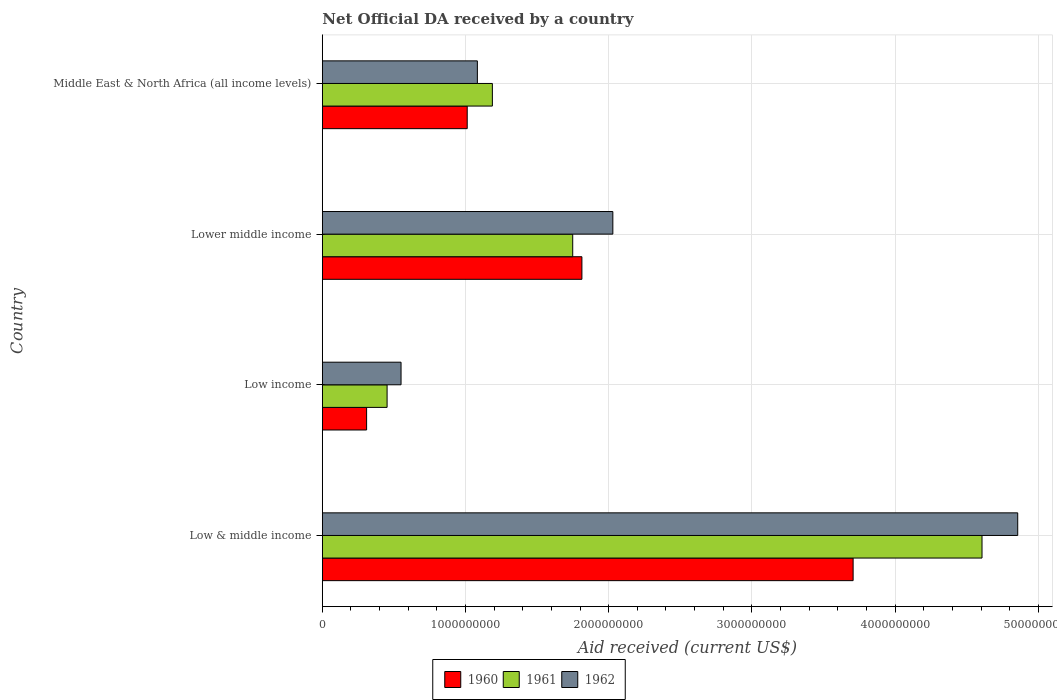How many different coloured bars are there?
Your answer should be very brief. 3. Are the number of bars per tick equal to the number of legend labels?
Offer a terse response. Yes. Are the number of bars on each tick of the Y-axis equal?
Keep it short and to the point. Yes. What is the label of the 1st group of bars from the top?
Offer a very short reply. Middle East & North Africa (all income levels). What is the net official development assistance aid received in 1960 in Lower middle income?
Your response must be concise. 1.81e+09. Across all countries, what is the maximum net official development assistance aid received in 1960?
Offer a terse response. 3.71e+09. Across all countries, what is the minimum net official development assistance aid received in 1960?
Provide a succinct answer. 3.09e+08. What is the total net official development assistance aid received in 1962 in the graph?
Your response must be concise. 8.52e+09. What is the difference between the net official development assistance aid received in 1960 in Low & middle income and that in Lower middle income?
Offer a very short reply. 1.89e+09. What is the difference between the net official development assistance aid received in 1961 in Low & middle income and the net official development assistance aid received in 1962 in Middle East & North Africa (all income levels)?
Give a very brief answer. 3.52e+09. What is the average net official development assistance aid received in 1960 per country?
Offer a very short reply. 1.71e+09. What is the difference between the net official development assistance aid received in 1960 and net official development assistance aid received in 1962 in Middle East & North Africa (all income levels)?
Your answer should be very brief. -7.09e+07. In how many countries, is the net official development assistance aid received in 1961 greater than 3000000000 US$?
Your answer should be compact. 1. What is the ratio of the net official development assistance aid received in 1960 in Low income to that in Middle East & North Africa (all income levels)?
Give a very brief answer. 0.31. Is the net official development assistance aid received in 1960 in Low & middle income less than that in Low income?
Provide a succinct answer. No. Is the difference between the net official development assistance aid received in 1960 in Lower middle income and Middle East & North Africa (all income levels) greater than the difference between the net official development assistance aid received in 1962 in Lower middle income and Middle East & North Africa (all income levels)?
Make the answer very short. No. What is the difference between the highest and the second highest net official development assistance aid received in 1960?
Give a very brief answer. 1.89e+09. What is the difference between the highest and the lowest net official development assistance aid received in 1961?
Your response must be concise. 4.15e+09. In how many countries, is the net official development assistance aid received in 1961 greater than the average net official development assistance aid received in 1961 taken over all countries?
Provide a succinct answer. 1. What does the 2nd bar from the bottom in Low income represents?
Ensure brevity in your answer.  1961. Are all the bars in the graph horizontal?
Your answer should be very brief. Yes. How many countries are there in the graph?
Offer a very short reply. 4. Are the values on the major ticks of X-axis written in scientific E-notation?
Provide a succinct answer. No. Does the graph contain grids?
Your answer should be very brief. Yes. Where does the legend appear in the graph?
Offer a very short reply. Bottom center. How many legend labels are there?
Your answer should be very brief. 3. How are the legend labels stacked?
Ensure brevity in your answer.  Horizontal. What is the title of the graph?
Ensure brevity in your answer.  Net Official DA received by a country. Does "1994" appear as one of the legend labels in the graph?
Keep it short and to the point. No. What is the label or title of the X-axis?
Keep it short and to the point. Aid received (current US$). What is the Aid received (current US$) in 1960 in Low & middle income?
Make the answer very short. 3.71e+09. What is the Aid received (current US$) of 1961 in Low & middle income?
Provide a short and direct response. 4.61e+09. What is the Aid received (current US$) of 1962 in Low & middle income?
Give a very brief answer. 4.86e+09. What is the Aid received (current US$) in 1960 in Low income?
Make the answer very short. 3.09e+08. What is the Aid received (current US$) of 1961 in Low income?
Your answer should be compact. 4.52e+08. What is the Aid received (current US$) in 1962 in Low income?
Your answer should be compact. 5.50e+08. What is the Aid received (current US$) in 1960 in Lower middle income?
Offer a terse response. 1.81e+09. What is the Aid received (current US$) of 1961 in Lower middle income?
Your response must be concise. 1.75e+09. What is the Aid received (current US$) in 1962 in Lower middle income?
Offer a terse response. 2.03e+09. What is the Aid received (current US$) in 1960 in Middle East & North Africa (all income levels)?
Offer a very short reply. 1.01e+09. What is the Aid received (current US$) of 1961 in Middle East & North Africa (all income levels)?
Your response must be concise. 1.19e+09. What is the Aid received (current US$) in 1962 in Middle East & North Africa (all income levels)?
Offer a very short reply. 1.08e+09. Across all countries, what is the maximum Aid received (current US$) in 1960?
Provide a short and direct response. 3.71e+09. Across all countries, what is the maximum Aid received (current US$) of 1961?
Your answer should be very brief. 4.61e+09. Across all countries, what is the maximum Aid received (current US$) of 1962?
Keep it short and to the point. 4.86e+09. Across all countries, what is the minimum Aid received (current US$) in 1960?
Give a very brief answer. 3.09e+08. Across all countries, what is the minimum Aid received (current US$) in 1961?
Provide a succinct answer. 4.52e+08. Across all countries, what is the minimum Aid received (current US$) in 1962?
Keep it short and to the point. 5.50e+08. What is the total Aid received (current US$) of 1960 in the graph?
Offer a very short reply. 6.84e+09. What is the total Aid received (current US$) in 1961 in the graph?
Your response must be concise. 8.00e+09. What is the total Aid received (current US$) in 1962 in the graph?
Make the answer very short. 8.52e+09. What is the difference between the Aid received (current US$) of 1960 in Low & middle income and that in Low income?
Your answer should be very brief. 3.40e+09. What is the difference between the Aid received (current US$) in 1961 in Low & middle income and that in Low income?
Your answer should be very brief. 4.15e+09. What is the difference between the Aid received (current US$) of 1962 in Low & middle income and that in Low income?
Ensure brevity in your answer.  4.31e+09. What is the difference between the Aid received (current US$) in 1960 in Low & middle income and that in Lower middle income?
Your answer should be compact. 1.89e+09. What is the difference between the Aid received (current US$) in 1961 in Low & middle income and that in Lower middle income?
Offer a very short reply. 2.86e+09. What is the difference between the Aid received (current US$) in 1962 in Low & middle income and that in Lower middle income?
Your response must be concise. 2.83e+09. What is the difference between the Aid received (current US$) in 1960 in Low & middle income and that in Middle East & North Africa (all income levels)?
Offer a terse response. 2.70e+09. What is the difference between the Aid received (current US$) in 1961 in Low & middle income and that in Middle East & North Africa (all income levels)?
Make the answer very short. 3.42e+09. What is the difference between the Aid received (current US$) of 1962 in Low & middle income and that in Middle East & North Africa (all income levels)?
Your response must be concise. 3.77e+09. What is the difference between the Aid received (current US$) of 1960 in Low income and that in Lower middle income?
Make the answer very short. -1.50e+09. What is the difference between the Aid received (current US$) in 1961 in Low income and that in Lower middle income?
Your answer should be very brief. -1.30e+09. What is the difference between the Aid received (current US$) of 1962 in Low income and that in Lower middle income?
Make the answer very short. -1.48e+09. What is the difference between the Aid received (current US$) of 1960 in Low income and that in Middle East & North Africa (all income levels)?
Offer a very short reply. -7.03e+08. What is the difference between the Aid received (current US$) in 1961 in Low income and that in Middle East & North Africa (all income levels)?
Make the answer very short. -7.35e+08. What is the difference between the Aid received (current US$) of 1962 in Low income and that in Middle East & North Africa (all income levels)?
Provide a succinct answer. -5.33e+08. What is the difference between the Aid received (current US$) in 1960 in Lower middle income and that in Middle East & North Africa (all income levels)?
Provide a succinct answer. 8.01e+08. What is the difference between the Aid received (current US$) in 1961 in Lower middle income and that in Middle East & North Africa (all income levels)?
Provide a succinct answer. 5.61e+08. What is the difference between the Aid received (current US$) in 1962 in Lower middle income and that in Middle East & North Africa (all income levels)?
Your response must be concise. 9.46e+08. What is the difference between the Aid received (current US$) of 1960 in Low & middle income and the Aid received (current US$) of 1961 in Low income?
Keep it short and to the point. 3.25e+09. What is the difference between the Aid received (current US$) in 1960 in Low & middle income and the Aid received (current US$) in 1962 in Low income?
Make the answer very short. 3.16e+09. What is the difference between the Aid received (current US$) of 1961 in Low & middle income and the Aid received (current US$) of 1962 in Low income?
Your answer should be very brief. 4.06e+09. What is the difference between the Aid received (current US$) in 1960 in Low & middle income and the Aid received (current US$) in 1961 in Lower middle income?
Provide a succinct answer. 1.96e+09. What is the difference between the Aid received (current US$) of 1960 in Low & middle income and the Aid received (current US$) of 1962 in Lower middle income?
Keep it short and to the point. 1.68e+09. What is the difference between the Aid received (current US$) of 1961 in Low & middle income and the Aid received (current US$) of 1962 in Lower middle income?
Make the answer very short. 2.58e+09. What is the difference between the Aid received (current US$) of 1960 in Low & middle income and the Aid received (current US$) of 1961 in Middle East & North Africa (all income levels)?
Keep it short and to the point. 2.52e+09. What is the difference between the Aid received (current US$) in 1960 in Low & middle income and the Aid received (current US$) in 1962 in Middle East & North Africa (all income levels)?
Give a very brief answer. 2.62e+09. What is the difference between the Aid received (current US$) of 1961 in Low & middle income and the Aid received (current US$) of 1962 in Middle East & North Africa (all income levels)?
Ensure brevity in your answer.  3.52e+09. What is the difference between the Aid received (current US$) of 1960 in Low income and the Aid received (current US$) of 1961 in Lower middle income?
Your answer should be compact. -1.44e+09. What is the difference between the Aid received (current US$) of 1960 in Low income and the Aid received (current US$) of 1962 in Lower middle income?
Offer a terse response. -1.72e+09. What is the difference between the Aid received (current US$) in 1961 in Low income and the Aid received (current US$) in 1962 in Lower middle income?
Offer a very short reply. -1.58e+09. What is the difference between the Aid received (current US$) in 1960 in Low income and the Aid received (current US$) in 1961 in Middle East & North Africa (all income levels)?
Provide a succinct answer. -8.78e+08. What is the difference between the Aid received (current US$) in 1960 in Low income and the Aid received (current US$) in 1962 in Middle East & North Africa (all income levels)?
Your response must be concise. -7.74e+08. What is the difference between the Aid received (current US$) in 1961 in Low income and the Aid received (current US$) in 1962 in Middle East & North Africa (all income levels)?
Provide a succinct answer. -6.30e+08. What is the difference between the Aid received (current US$) of 1960 in Lower middle income and the Aid received (current US$) of 1961 in Middle East & North Africa (all income levels)?
Give a very brief answer. 6.25e+08. What is the difference between the Aid received (current US$) of 1960 in Lower middle income and the Aid received (current US$) of 1962 in Middle East & North Africa (all income levels)?
Offer a terse response. 7.30e+08. What is the difference between the Aid received (current US$) in 1961 in Lower middle income and the Aid received (current US$) in 1962 in Middle East & North Africa (all income levels)?
Provide a short and direct response. 6.66e+08. What is the average Aid received (current US$) in 1960 per country?
Your answer should be compact. 1.71e+09. What is the average Aid received (current US$) of 1961 per country?
Provide a short and direct response. 2.00e+09. What is the average Aid received (current US$) in 1962 per country?
Offer a terse response. 2.13e+09. What is the difference between the Aid received (current US$) in 1960 and Aid received (current US$) in 1961 in Low & middle income?
Your answer should be compact. -9.00e+08. What is the difference between the Aid received (current US$) of 1960 and Aid received (current US$) of 1962 in Low & middle income?
Make the answer very short. -1.15e+09. What is the difference between the Aid received (current US$) in 1961 and Aid received (current US$) in 1962 in Low & middle income?
Make the answer very short. -2.49e+08. What is the difference between the Aid received (current US$) of 1960 and Aid received (current US$) of 1961 in Low income?
Keep it short and to the point. -1.43e+08. What is the difference between the Aid received (current US$) in 1960 and Aid received (current US$) in 1962 in Low income?
Keep it short and to the point. -2.41e+08. What is the difference between the Aid received (current US$) in 1961 and Aid received (current US$) in 1962 in Low income?
Your answer should be very brief. -9.75e+07. What is the difference between the Aid received (current US$) in 1960 and Aid received (current US$) in 1961 in Lower middle income?
Keep it short and to the point. 6.42e+07. What is the difference between the Aid received (current US$) in 1960 and Aid received (current US$) in 1962 in Lower middle income?
Keep it short and to the point. -2.16e+08. What is the difference between the Aid received (current US$) of 1961 and Aid received (current US$) of 1962 in Lower middle income?
Keep it short and to the point. -2.80e+08. What is the difference between the Aid received (current US$) of 1960 and Aid received (current US$) of 1961 in Middle East & North Africa (all income levels)?
Keep it short and to the point. -1.76e+08. What is the difference between the Aid received (current US$) of 1960 and Aid received (current US$) of 1962 in Middle East & North Africa (all income levels)?
Offer a very short reply. -7.09e+07. What is the difference between the Aid received (current US$) of 1961 and Aid received (current US$) of 1962 in Middle East & North Africa (all income levels)?
Offer a terse response. 1.05e+08. What is the ratio of the Aid received (current US$) in 1960 in Low & middle income to that in Low income?
Your response must be concise. 11.99. What is the ratio of the Aid received (current US$) in 1961 in Low & middle income to that in Low income?
Give a very brief answer. 10.19. What is the ratio of the Aid received (current US$) in 1962 in Low & middle income to that in Low income?
Your answer should be very brief. 8.83. What is the ratio of the Aid received (current US$) in 1960 in Low & middle income to that in Lower middle income?
Make the answer very short. 2.04. What is the ratio of the Aid received (current US$) of 1961 in Low & middle income to that in Lower middle income?
Offer a terse response. 2.63. What is the ratio of the Aid received (current US$) in 1962 in Low & middle income to that in Lower middle income?
Your answer should be compact. 2.39. What is the ratio of the Aid received (current US$) in 1960 in Low & middle income to that in Middle East & North Africa (all income levels)?
Your answer should be compact. 3.66. What is the ratio of the Aid received (current US$) in 1961 in Low & middle income to that in Middle East & North Africa (all income levels)?
Provide a succinct answer. 3.88. What is the ratio of the Aid received (current US$) in 1962 in Low & middle income to that in Middle East & North Africa (all income levels)?
Your answer should be very brief. 4.49. What is the ratio of the Aid received (current US$) of 1960 in Low income to that in Lower middle income?
Offer a terse response. 0.17. What is the ratio of the Aid received (current US$) of 1961 in Low income to that in Lower middle income?
Make the answer very short. 0.26. What is the ratio of the Aid received (current US$) in 1962 in Low income to that in Lower middle income?
Ensure brevity in your answer.  0.27. What is the ratio of the Aid received (current US$) in 1960 in Low income to that in Middle East & North Africa (all income levels)?
Offer a terse response. 0.31. What is the ratio of the Aid received (current US$) of 1961 in Low income to that in Middle East & North Africa (all income levels)?
Your answer should be compact. 0.38. What is the ratio of the Aid received (current US$) in 1962 in Low income to that in Middle East & North Africa (all income levels)?
Ensure brevity in your answer.  0.51. What is the ratio of the Aid received (current US$) of 1960 in Lower middle income to that in Middle East & North Africa (all income levels)?
Provide a short and direct response. 1.79. What is the ratio of the Aid received (current US$) of 1961 in Lower middle income to that in Middle East & North Africa (all income levels)?
Offer a terse response. 1.47. What is the ratio of the Aid received (current US$) in 1962 in Lower middle income to that in Middle East & North Africa (all income levels)?
Provide a short and direct response. 1.87. What is the difference between the highest and the second highest Aid received (current US$) in 1960?
Make the answer very short. 1.89e+09. What is the difference between the highest and the second highest Aid received (current US$) in 1961?
Your answer should be very brief. 2.86e+09. What is the difference between the highest and the second highest Aid received (current US$) in 1962?
Offer a very short reply. 2.83e+09. What is the difference between the highest and the lowest Aid received (current US$) of 1960?
Offer a very short reply. 3.40e+09. What is the difference between the highest and the lowest Aid received (current US$) of 1961?
Your answer should be compact. 4.15e+09. What is the difference between the highest and the lowest Aid received (current US$) in 1962?
Offer a terse response. 4.31e+09. 